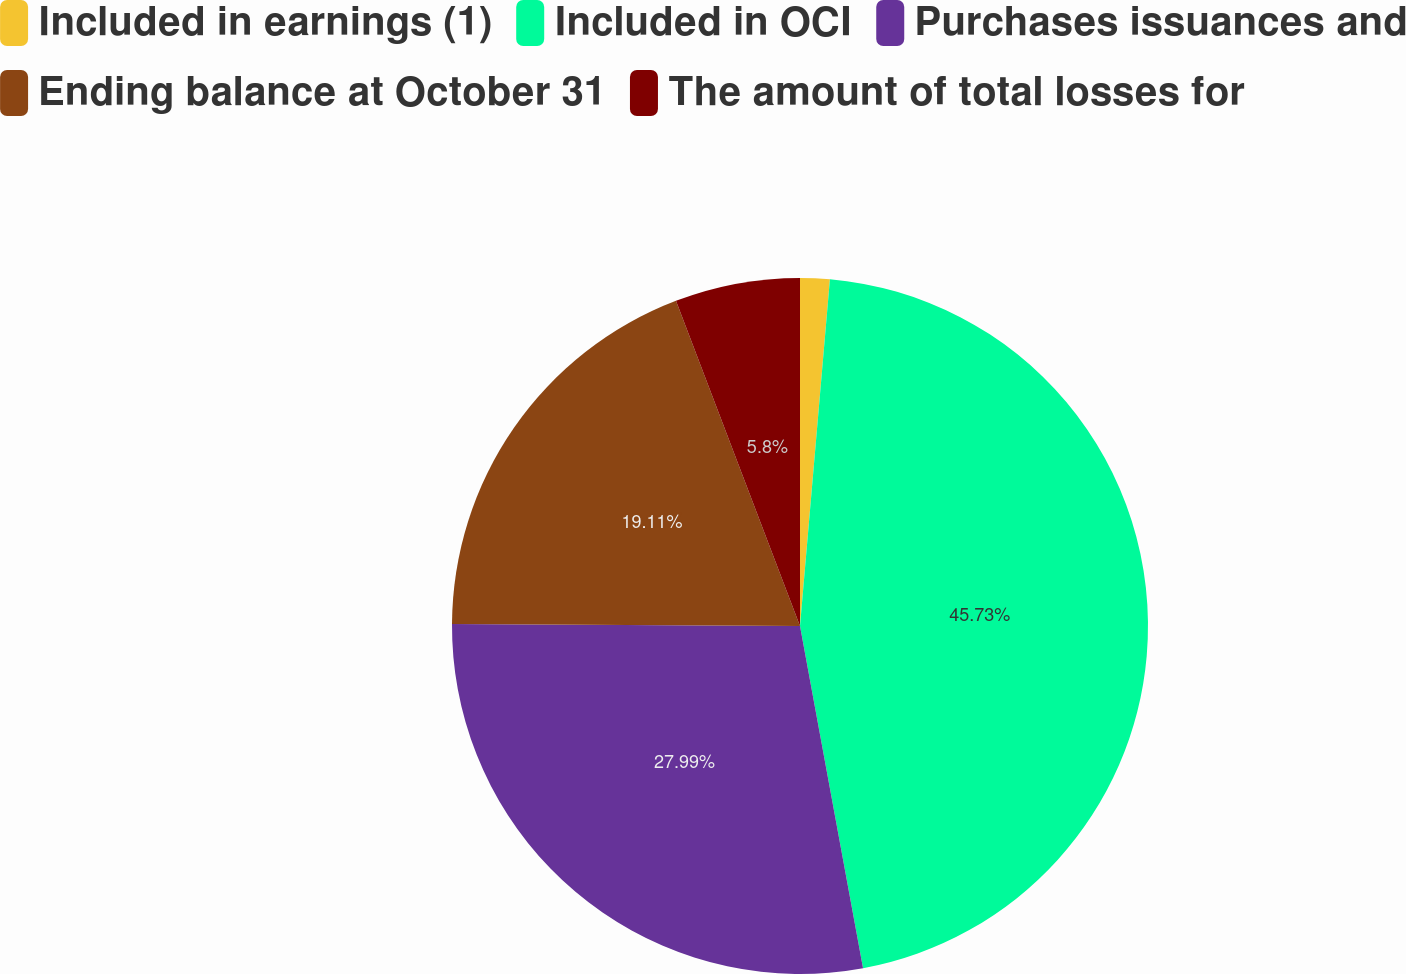Convert chart to OTSL. <chart><loc_0><loc_0><loc_500><loc_500><pie_chart><fcel>Included in earnings (1)<fcel>Included in OCI<fcel>Purchases issuances and<fcel>Ending balance at October 31<fcel>The amount of total losses for<nl><fcel>1.37%<fcel>45.73%<fcel>27.99%<fcel>19.11%<fcel>5.8%<nl></chart> 